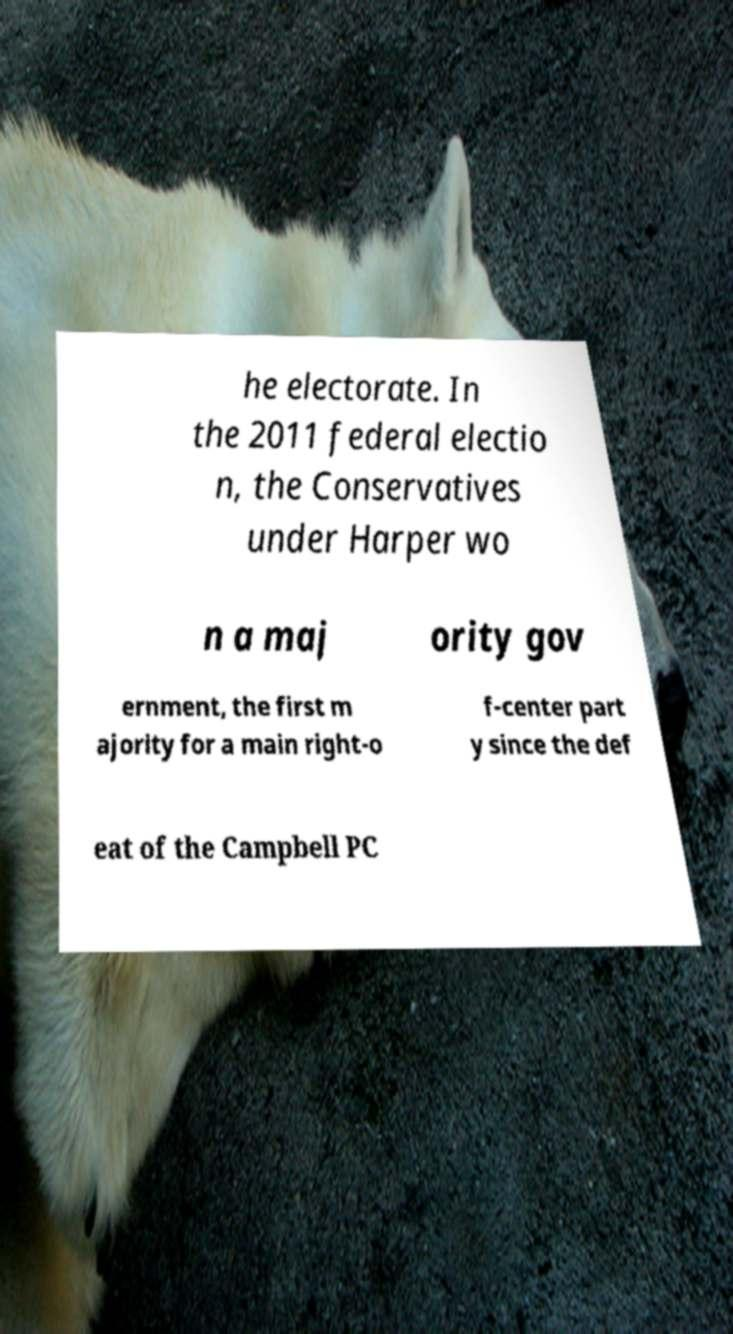Please identify and transcribe the text found in this image. he electorate. In the 2011 federal electio n, the Conservatives under Harper wo n a maj ority gov ernment, the first m ajority for a main right-o f-center part y since the def eat of the Campbell PC 